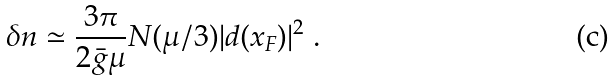Convert formula to latex. <formula><loc_0><loc_0><loc_500><loc_500>\delta n \simeq \frac { 3 \pi } { 2 { \bar { g } } \mu } N ( \mu / 3 ) | { d } ( x _ { F } ) | ^ { 2 } \ .</formula> 